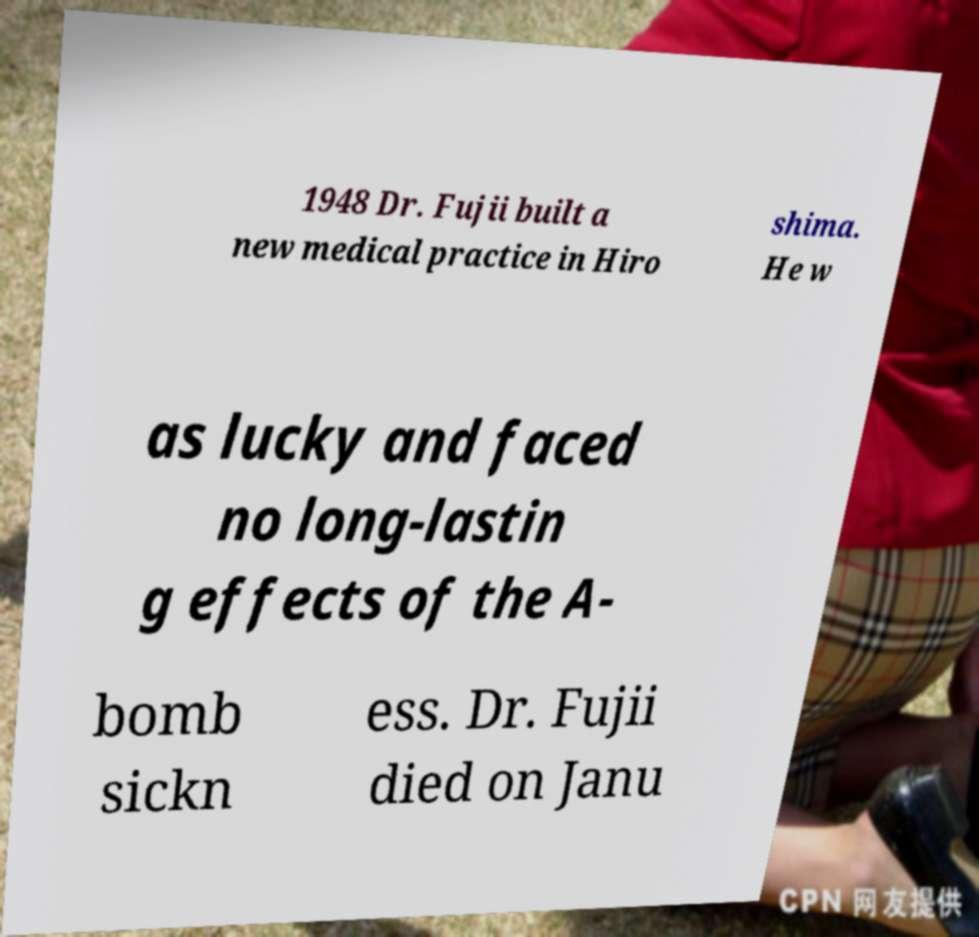Can you accurately transcribe the text from the provided image for me? 1948 Dr. Fujii built a new medical practice in Hiro shima. He w as lucky and faced no long-lastin g effects of the A- bomb sickn ess. Dr. Fujii died on Janu 